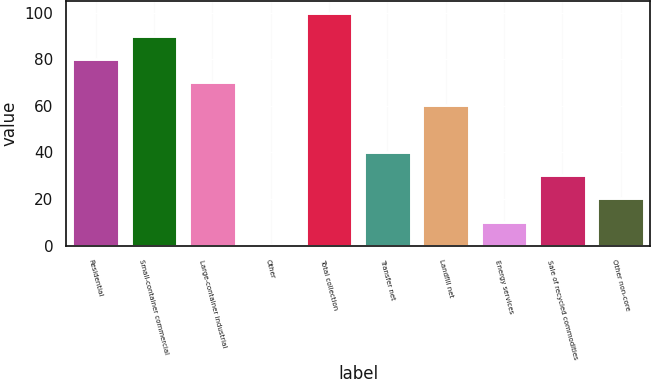Convert chart to OTSL. <chart><loc_0><loc_0><loc_500><loc_500><bar_chart><fcel>Residential<fcel>Small-container commercial<fcel>Large-container industrial<fcel>Other<fcel>Total collection<fcel>Transfer net<fcel>Landfill net<fcel>Energy services<fcel>Sale of recycled commodities<fcel>Other non-core<nl><fcel>80.08<fcel>90.04<fcel>70.12<fcel>0.4<fcel>100<fcel>40.24<fcel>60.16<fcel>10.36<fcel>30.28<fcel>20.32<nl></chart> 